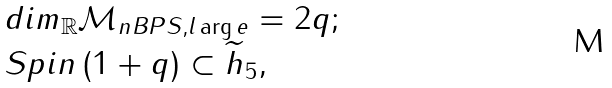Convert formula to latex. <formula><loc_0><loc_0><loc_500><loc_500>\begin{array} { l } d i m _ { \mathbb { R } } \mathcal { M } _ { n B P S , l \arg e } = 2 q ; \\ S p i n \left ( 1 + q \right ) \subset \widetilde { h } _ { 5 } , \end{array}</formula> 